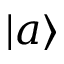Convert formula to latex. <formula><loc_0><loc_0><loc_500><loc_500>| a \rangle</formula> 